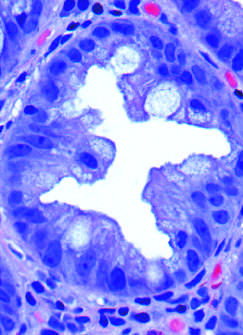what does epithelial crowding produce when glands are cut in cross-section?
Answer the question using a single word or phrase. A serrated architecture 